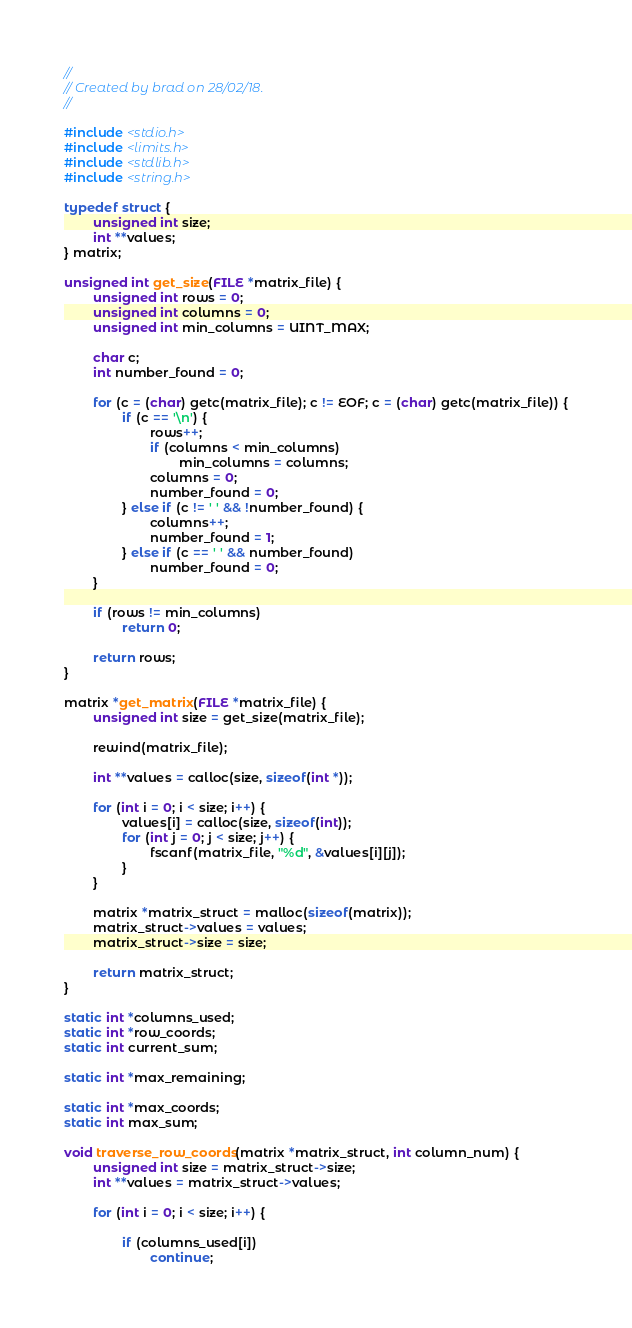Convert code to text. <code><loc_0><loc_0><loc_500><loc_500><_C_>//
// Created by brad on 28/02/18.
//

#include <stdio.h>
#include <limits.h>
#include <stdlib.h>
#include <string.h>

typedef struct {
        unsigned int size;
        int **values;
} matrix;

unsigned int get_size(FILE *matrix_file) {
        unsigned int rows = 0;
        unsigned int columns = 0;
        unsigned int min_columns = UINT_MAX;

        char c;
        int number_found = 0;

        for (c = (char) getc(matrix_file); c != EOF; c = (char) getc(matrix_file)) {
                if (c == '\n') {
                        rows++;
                        if (columns < min_columns)
                                min_columns = columns;
                        columns = 0;
                        number_found = 0;
                } else if (c != ' ' && !number_found) {
                        columns++;
                        number_found = 1;
                } else if (c == ' ' && number_found)
                        number_found = 0;
        }

        if (rows != min_columns)
                return 0;

        return rows;
}

matrix *get_matrix(FILE *matrix_file) {
        unsigned int size = get_size(matrix_file);

        rewind(matrix_file);

        int **values = calloc(size, sizeof(int *));

        for (int i = 0; i < size; i++) {
                values[i] = calloc(size, sizeof(int));
                for (int j = 0; j < size; j++) {
                        fscanf(matrix_file, "%d", &values[i][j]);
                }
        }

        matrix *matrix_struct = malloc(sizeof(matrix));
        matrix_struct->values = values;
        matrix_struct->size = size;

        return matrix_struct;
}

static int *columns_used;
static int *row_coords;
static int current_sum;

static int *max_remaining;

static int *max_coords;
static int max_sum;

void traverse_row_coords(matrix *matrix_struct, int column_num) {
        unsigned int size = matrix_struct->size;
        int **values = matrix_struct->values;

        for (int i = 0; i < size; i++) {

                if (columns_used[i])
                        continue;</code> 